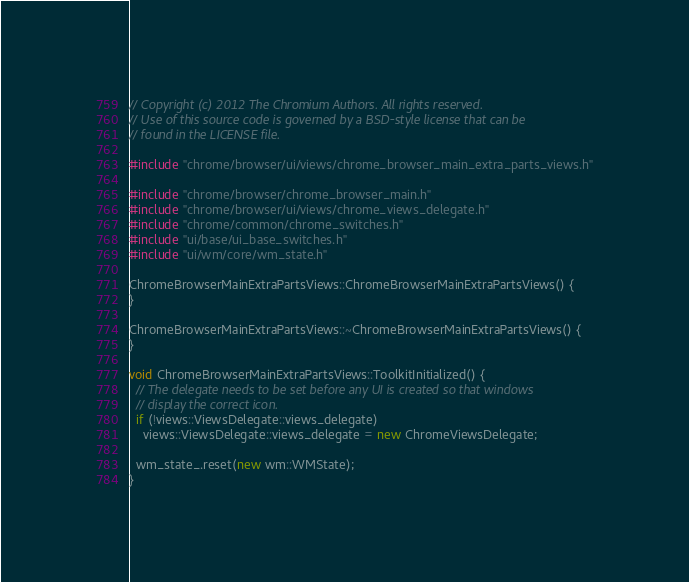Convert code to text. <code><loc_0><loc_0><loc_500><loc_500><_C++_>// Copyright (c) 2012 The Chromium Authors. All rights reserved.
// Use of this source code is governed by a BSD-style license that can be
// found in the LICENSE file.

#include "chrome/browser/ui/views/chrome_browser_main_extra_parts_views.h"

#include "chrome/browser/chrome_browser_main.h"
#include "chrome/browser/ui/views/chrome_views_delegate.h"
#include "chrome/common/chrome_switches.h"
#include "ui/base/ui_base_switches.h"
#include "ui/wm/core/wm_state.h"

ChromeBrowserMainExtraPartsViews::ChromeBrowserMainExtraPartsViews() {
}

ChromeBrowserMainExtraPartsViews::~ChromeBrowserMainExtraPartsViews() {
}

void ChromeBrowserMainExtraPartsViews::ToolkitInitialized() {
  // The delegate needs to be set before any UI is created so that windows
  // display the correct icon.
  if (!views::ViewsDelegate::views_delegate)
    views::ViewsDelegate::views_delegate = new ChromeViewsDelegate;

  wm_state_.reset(new wm::WMState);
}
</code> 